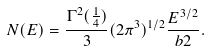<formula> <loc_0><loc_0><loc_500><loc_500>N ( E ) = \frac { \Gamma ^ { 2 } ( \frac { 1 } { 4 } ) } 3 ( 2 \pi ^ { 3 } ) ^ { 1 / 2 } \frac { E ^ { 3 / 2 } } { b { 2 } } .</formula> 